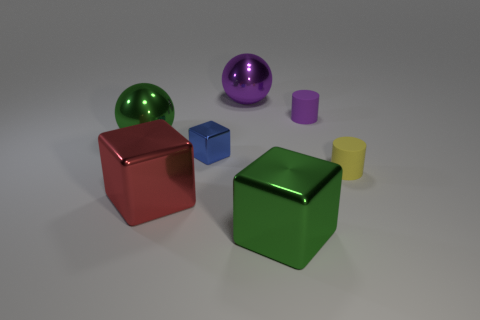Subtract all big blocks. How many blocks are left? 1 Add 2 big purple balls. How many objects exist? 9 Subtract all green balls. How many balls are left? 1 Subtract all cylinders. How many objects are left? 5 Subtract 2 blocks. How many blocks are left? 1 Subtract all purple cylinders. Subtract all yellow cubes. How many cylinders are left? 1 Subtract all red cylinders. How many green cubes are left? 1 Subtract all small matte things. Subtract all tiny yellow rubber things. How many objects are left? 4 Add 2 blocks. How many blocks are left? 5 Add 1 large red blocks. How many large red blocks exist? 2 